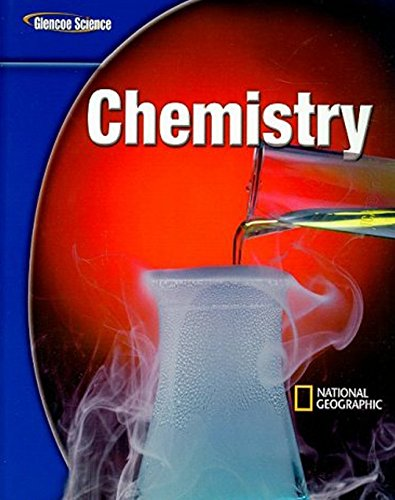Who is the author of this book? The cover does not specify an individual author, indicating that the book was likely collaboratively produced by educators and experts at McGraw-Hill Education. 